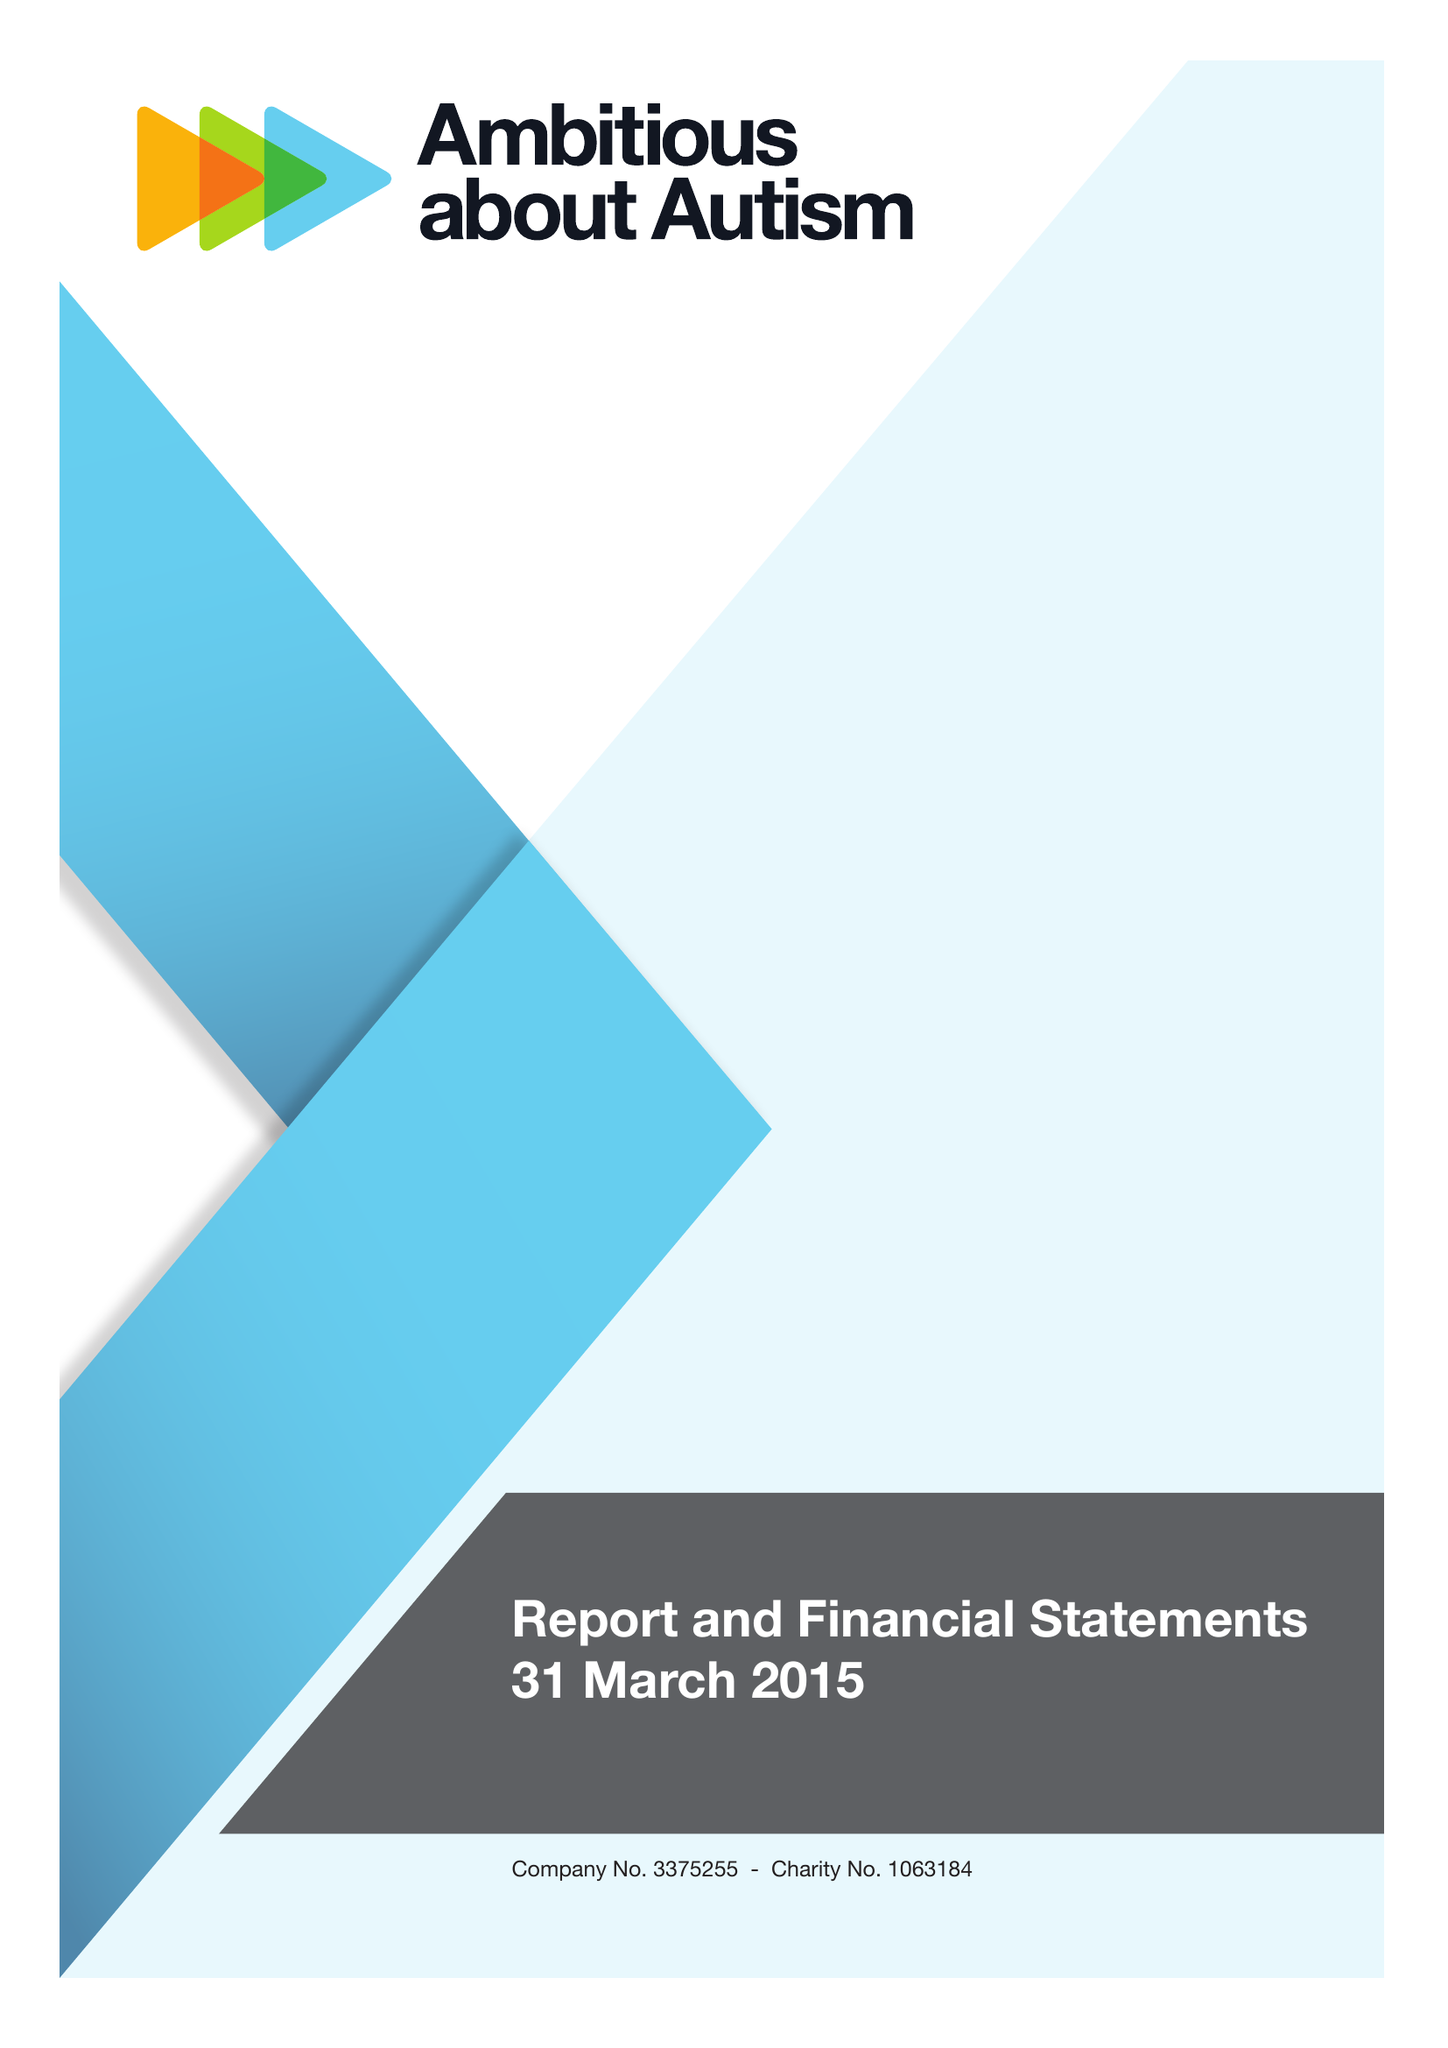What is the value for the spending_annually_in_british_pounds?
Answer the question using a single word or phrase. 9703000.00 